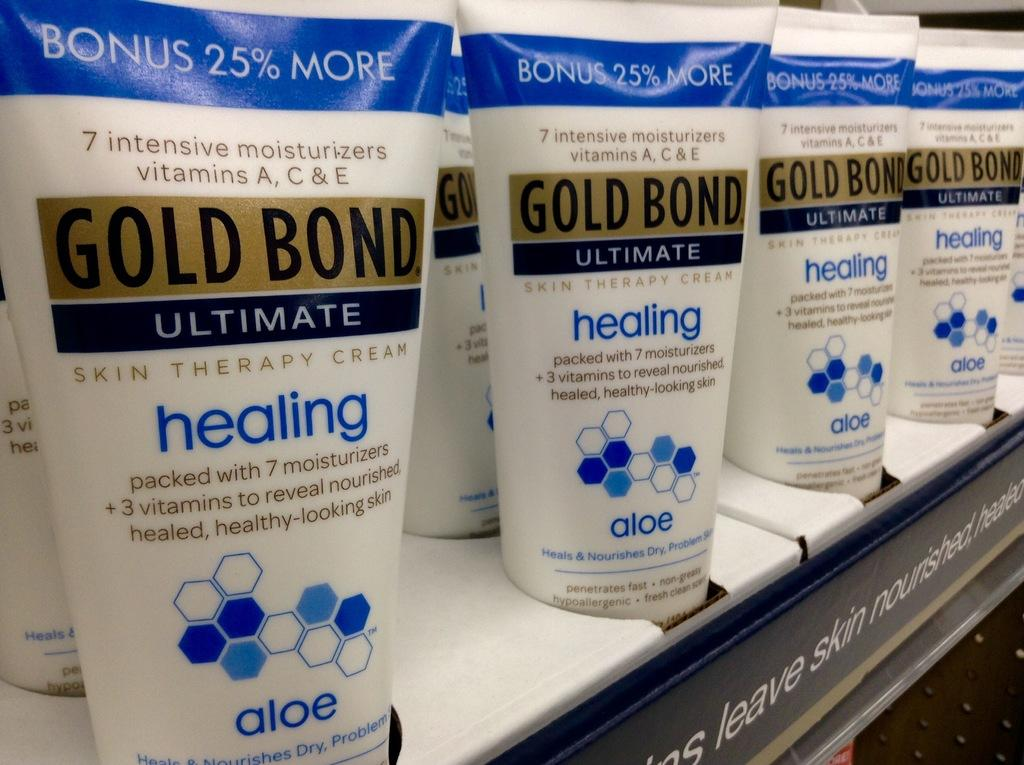<image>
Offer a succinct explanation of the picture presented. gold bond healing lotion is on a shelf to be purchased 